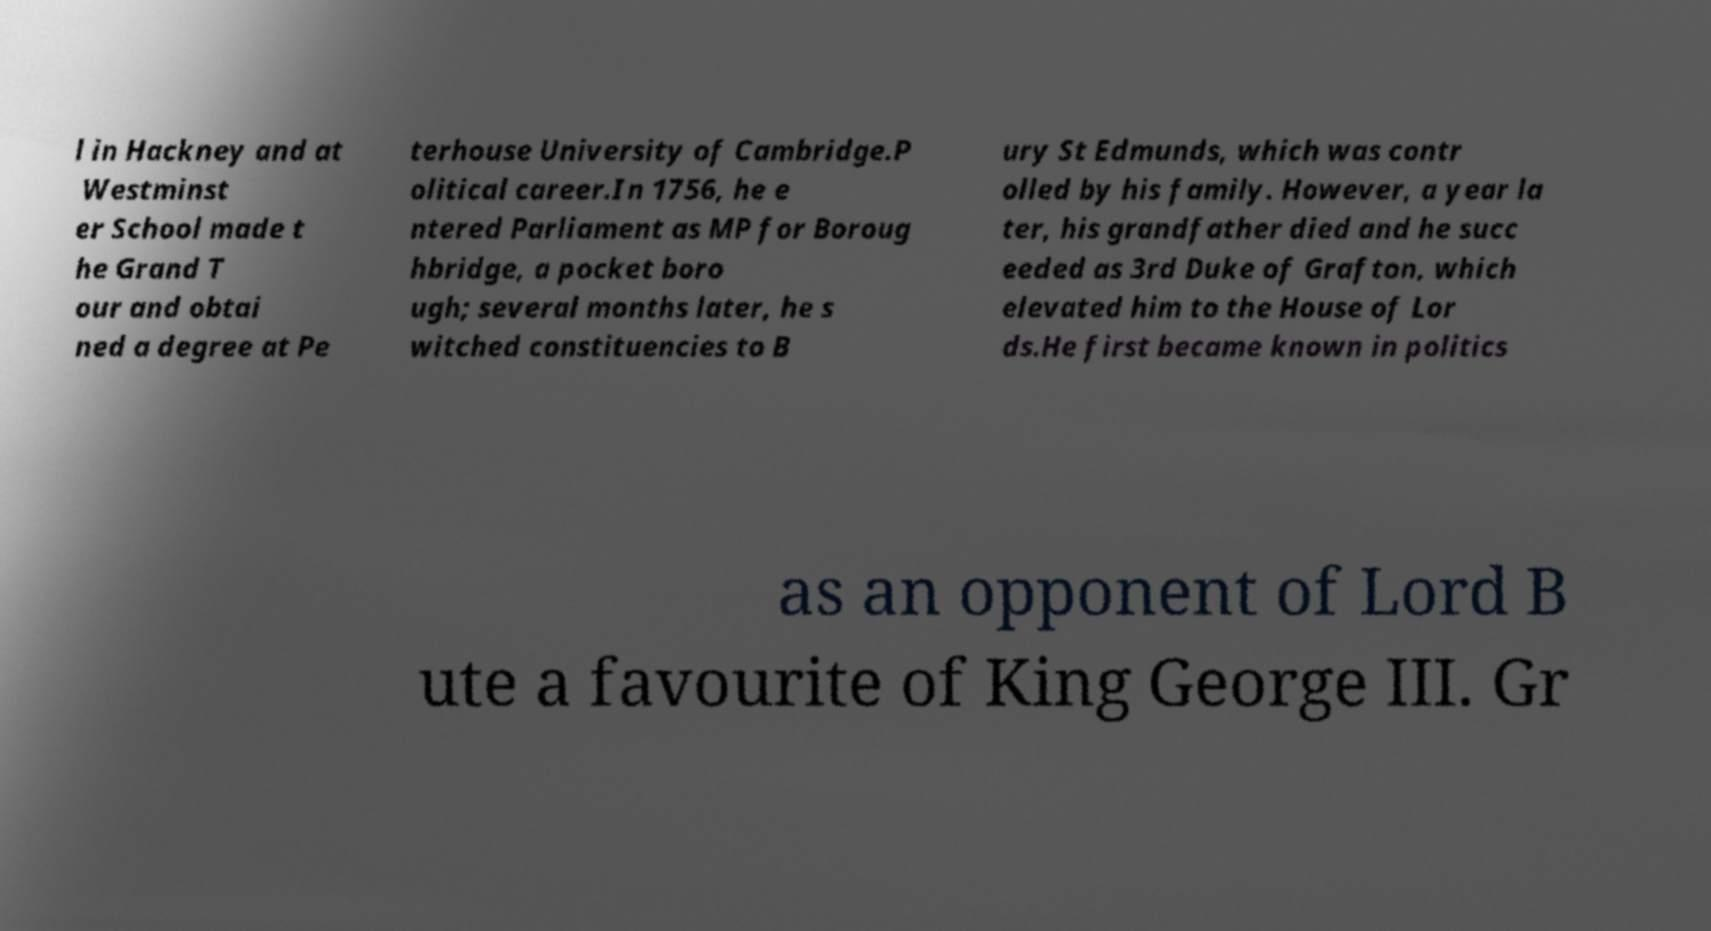What messages or text are displayed in this image? I need them in a readable, typed format. l in Hackney and at Westminst er School made t he Grand T our and obtai ned a degree at Pe terhouse University of Cambridge.P olitical career.In 1756, he e ntered Parliament as MP for Boroug hbridge, a pocket boro ugh; several months later, he s witched constituencies to B ury St Edmunds, which was contr olled by his family. However, a year la ter, his grandfather died and he succ eeded as 3rd Duke of Grafton, which elevated him to the House of Lor ds.He first became known in politics as an opponent of Lord B ute a favourite of King George III. Gr 